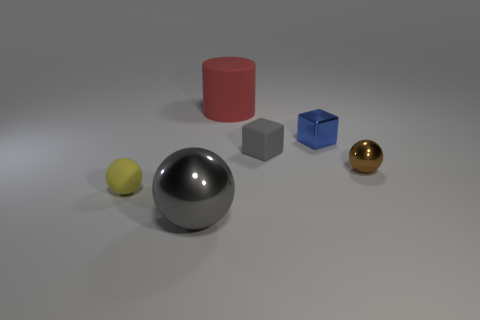How many other objects are there of the same size as the brown sphere?
Keep it short and to the point. 3. Is the number of tiny yellow rubber objects to the right of the blue cube the same as the number of blue cubes?
Offer a terse response. No. Does the small thing that is on the left side of the rubber block have the same color as the metal sphere in front of the yellow matte thing?
Your response must be concise. No. There is a sphere that is right of the rubber sphere and left of the matte cylinder; what is its material?
Offer a very short reply. Metal. The large sphere is what color?
Provide a short and direct response. Gray. How many other things are the same shape as the blue metal object?
Ensure brevity in your answer.  1. Are there the same number of tiny brown metal objects that are on the right side of the small metal block and metal balls that are behind the yellow object?
Offer a terse response. Yes. What is the large gray sphere made of?
Keep it short and to the point. Metal. What is the ball right of the small rubber cube made of?
Your answer should be very brief. Metal. Is the number of red things behind the big red cylinder greater than the number of large gray balls?
Keep it short and to the point. No. 